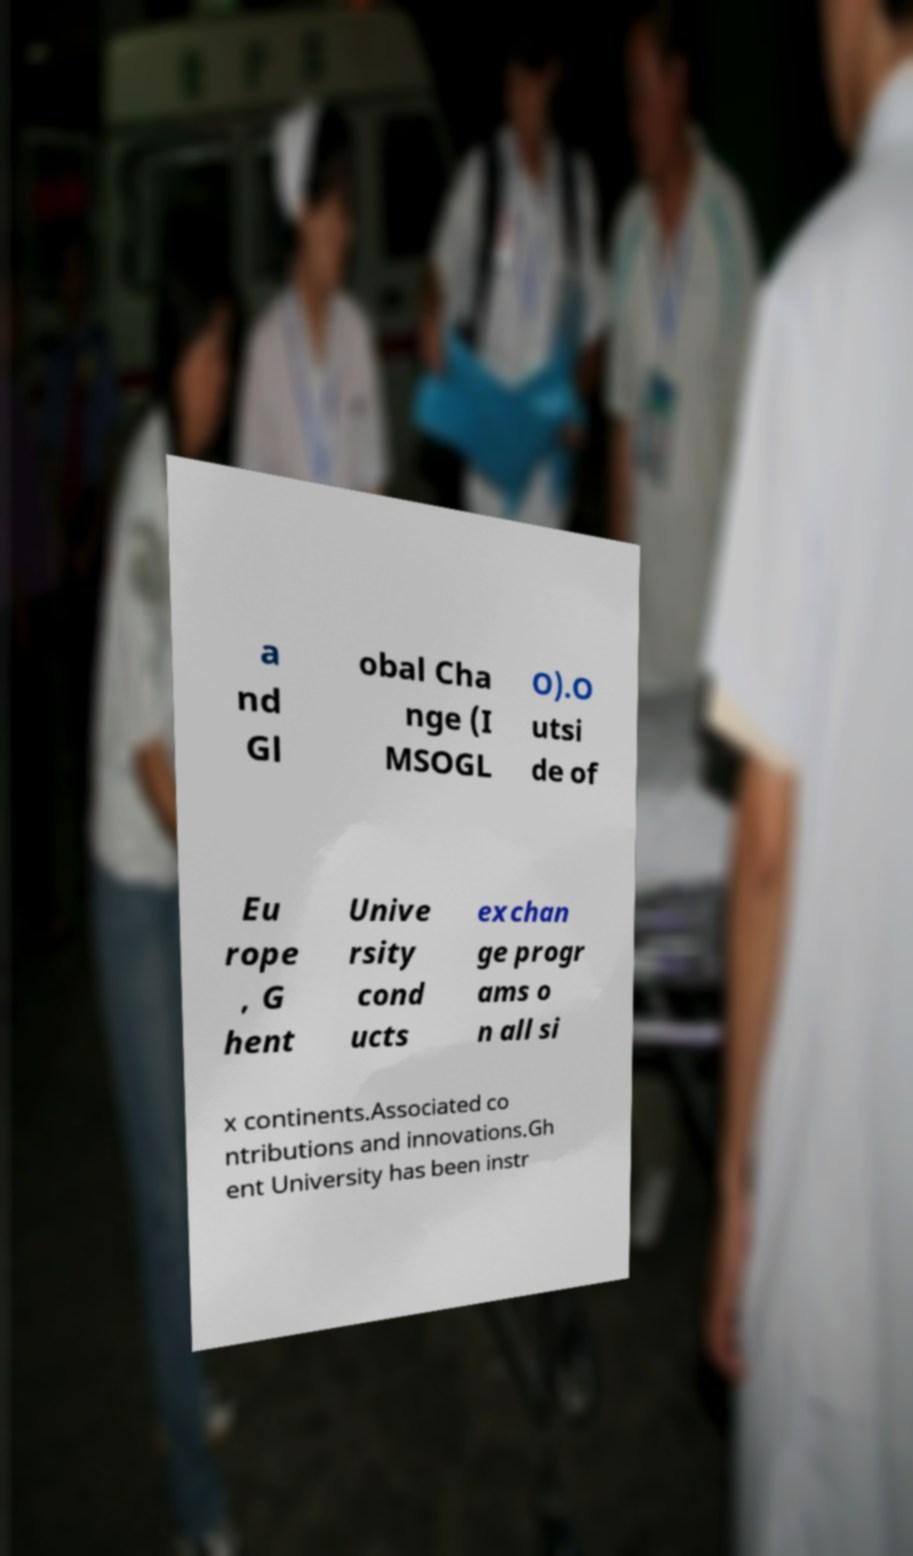Can you read and provide the text displayed in the image?This photo seems to have some interesting text. Can you extract and type it out for me? a nd Gl obal Cha nge (I MSOGL O).O utsi de of Eu rope , G hent Unive rsity cond ucts exchan ge progr ams o n all si x continents.Associated co ntributions and innovations.Gh ent University has been instr 